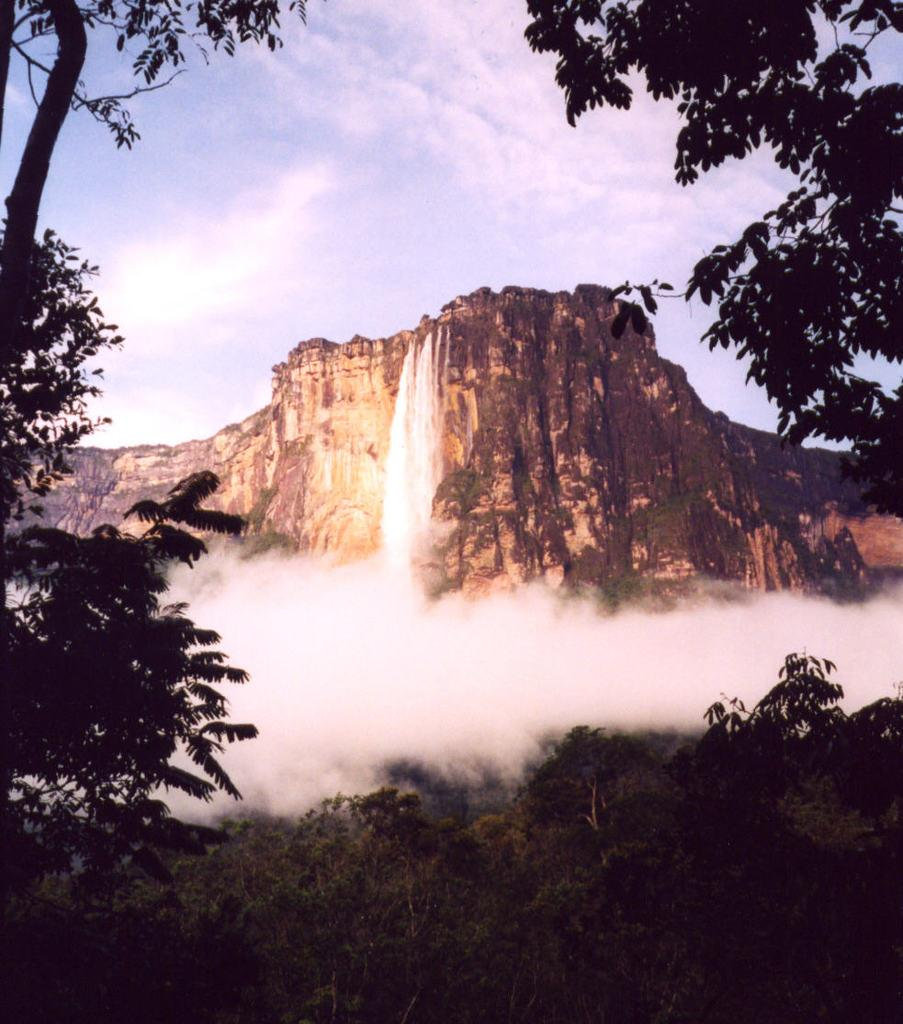What geographical feature is present in the image? There is a hill in the image. What is happening on the hill? There is water flow on the hill. What type of vegetation can be seen in the image? There is a group of trees in the image. What is visible in the background of the image? The sky is visible in the image. How would you describe the weather based on the appearance of the sky? The sky appears cloudy in the image. What type of soda is being poured on the hill in the image? There is no soda present in the image; it features a hill with water flow and a group of trees. What is your opinion on the artistic style of the image? The provided facts do not include any information about the artistic style of the image, so it is not possible to provide an opinion on it. 